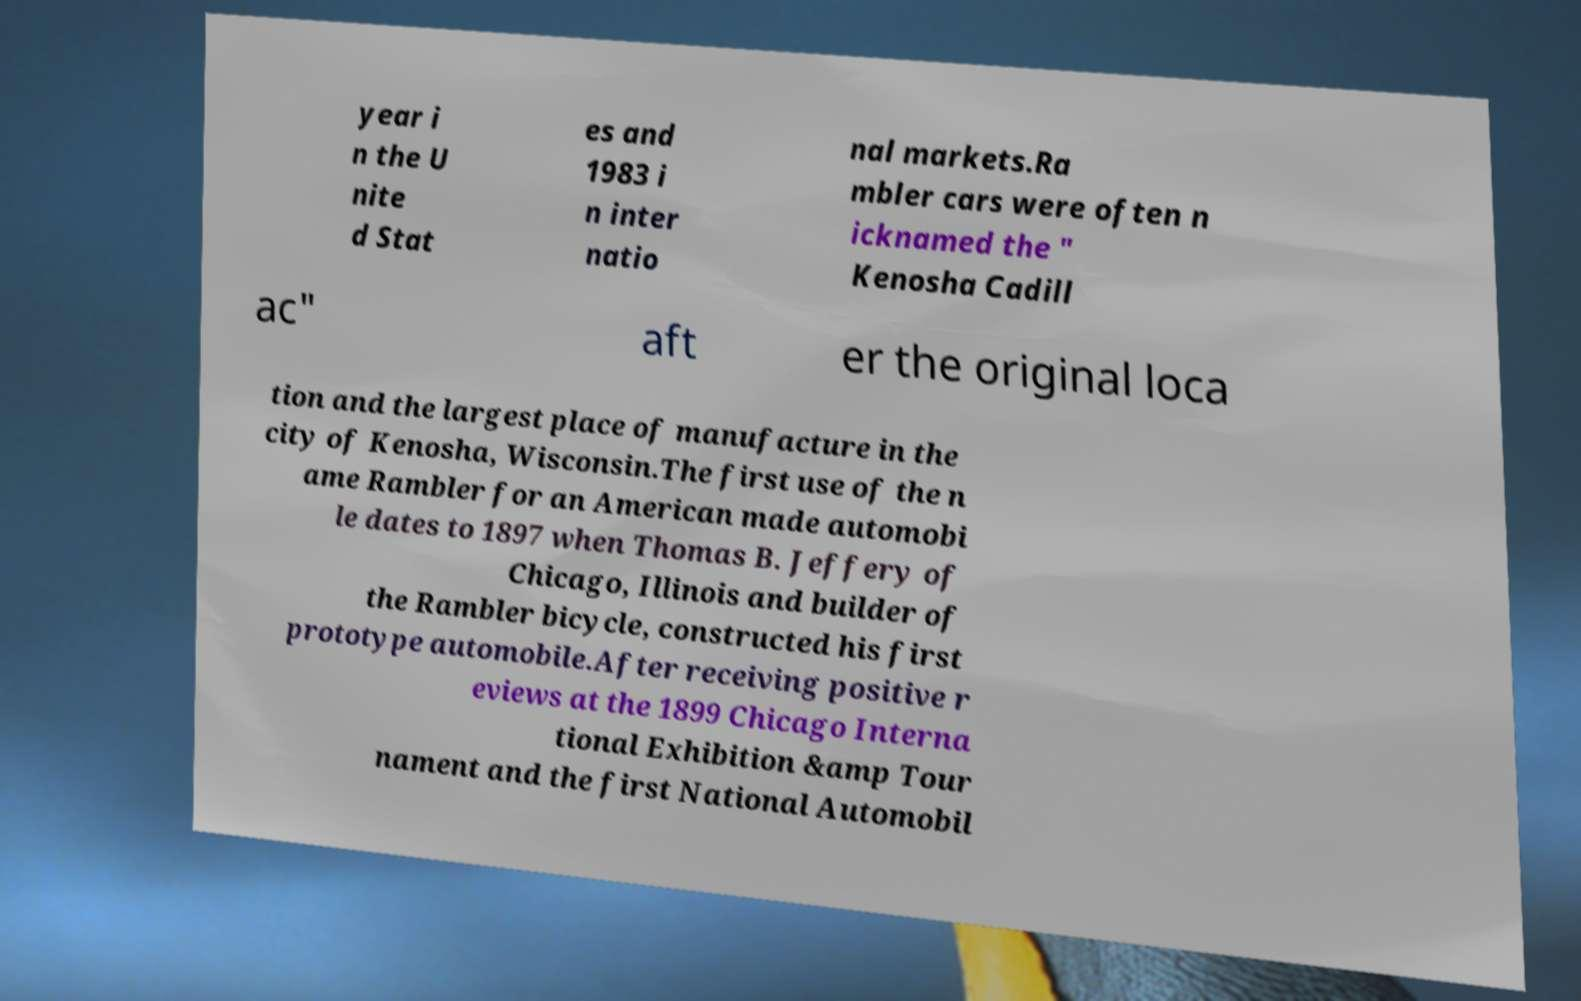Please read and relay the text visible in this image. What does it say? year i n the U nite d Stat es and 1983 i n inter natio nal markets.Ra mbler cars were often n icknamed the " Kenosha Cadill ac" aft er the original loca tion and the largest place of manufacture in the city of Kenosha, Wisconsin.The first use of the n ame Rambler for an American made automobi le dates to 1897 when Thomas B. Jeffery of Chicago, Illinois and builder of the Rambler bicycle, constructed his first prototype automobile.After receiving positive r eviews at the 1899 Chicago Interna tional Exhibition &amp Tour nament and the first National Automobil 